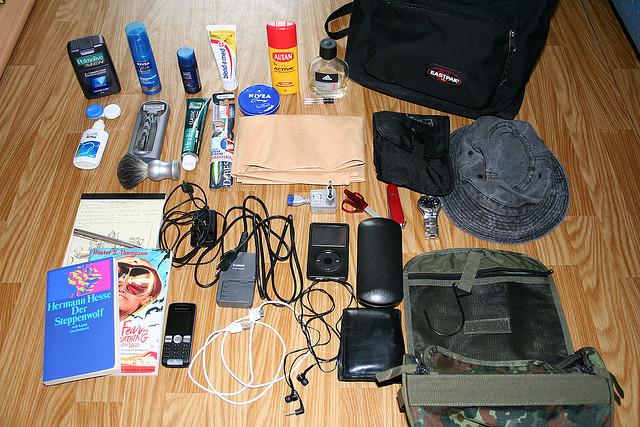What are the tools on the bottom row to the right called?
Short answer required. Earbuds. What color is the floor?
Keep it brief. Brown. How are these objects all used together?
Write a very short answer. Travel. Would these be a women's or man's belongings?
Answer briefly. Man's. 